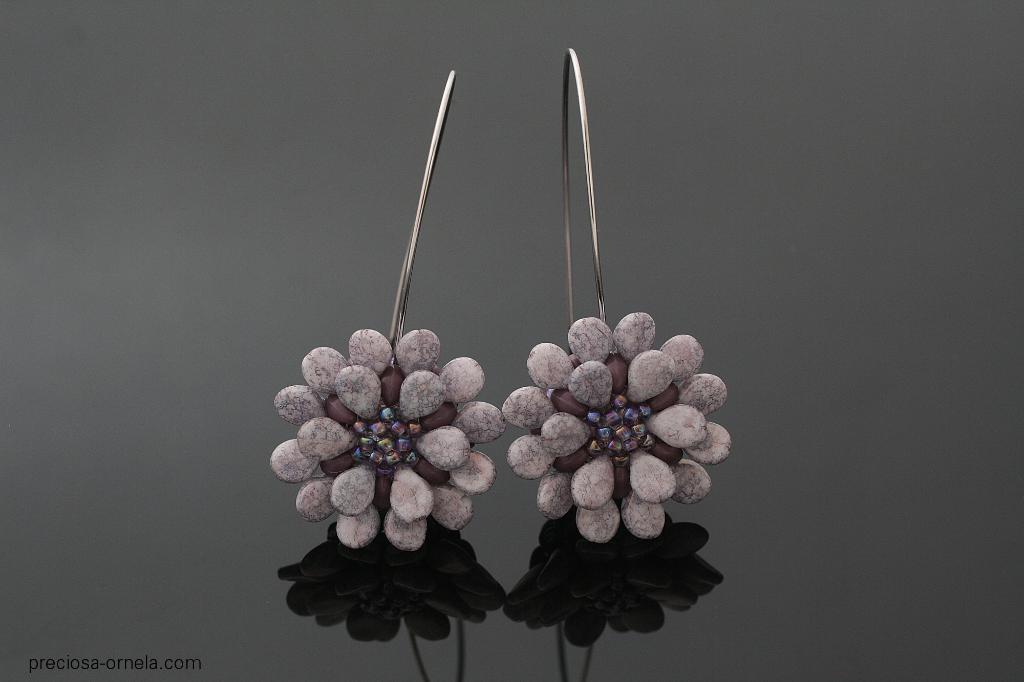What type of accessory is present in the image? There are earrings in the image. Can you describe the earrings in more detail? Unfortunately, the image does not provide enough detail to describe the earrings further. What type of food is being served on the pizzas in the image? There are no pizzas present in the image; it only features earrings. 